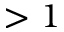Convert formula to latex. <formula><loc_0><loc_0><loc_500><loc_500>> 1</formula> 